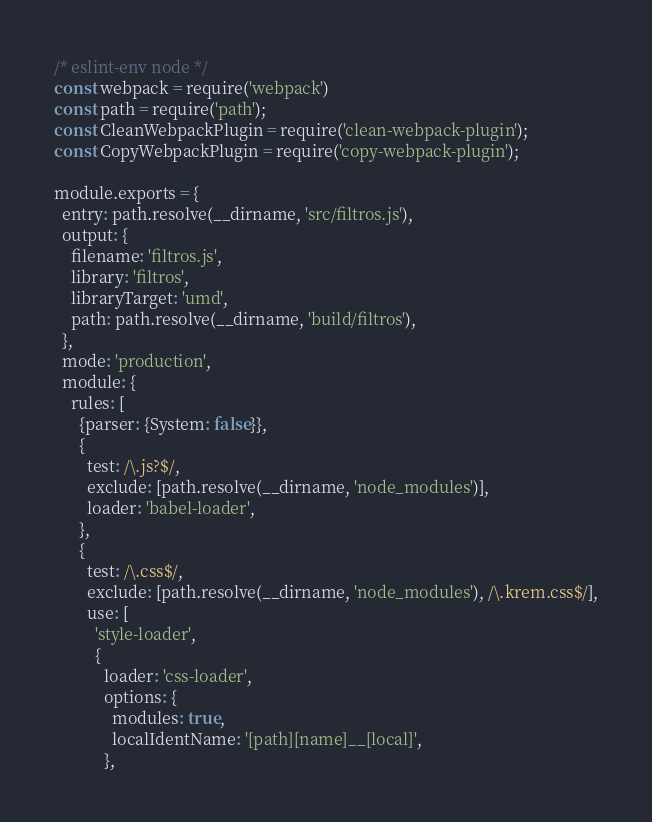Convert code to text. <code><loc_0><loc_0><loc_500><loc_500><_JavaScript_>/* eslint-env node */
const webpack = require('webpack')
const path = require('path');
const CleanWebpackPlugin = require('clean-webpack-plugin');
const CopyWebpackPlugin = require('copy-webpack-plugin');

module.exports = {
  entry: path.resolve(__dirname, 'src/filtros.js'),
  output: {
    filename: 'filtros.js',
    library: 'filtros',
    libraryTarget: 'umd',
    path: path.resolve(__dirname, 'build/filtros'),
  },
  mode: 'production',
  module: {
    rules: [
      {parser: {System: false}},
      {
        test: /\.js?$/,
        exclude: [path.resolve(__dirname, 'node_modules')],
        loader: 'babel-loader',
      },
      {
        test: /\.css$/,
        exclude: [path.resolve(__dirname, 'node_modules'), /\.krem.css$/],
        use: [
          'style-loader',
          {
            loader: 'css-loader',
            options: {
              modules: true,
              localIdentName: '[path][name]__[local]',
            },</code> 